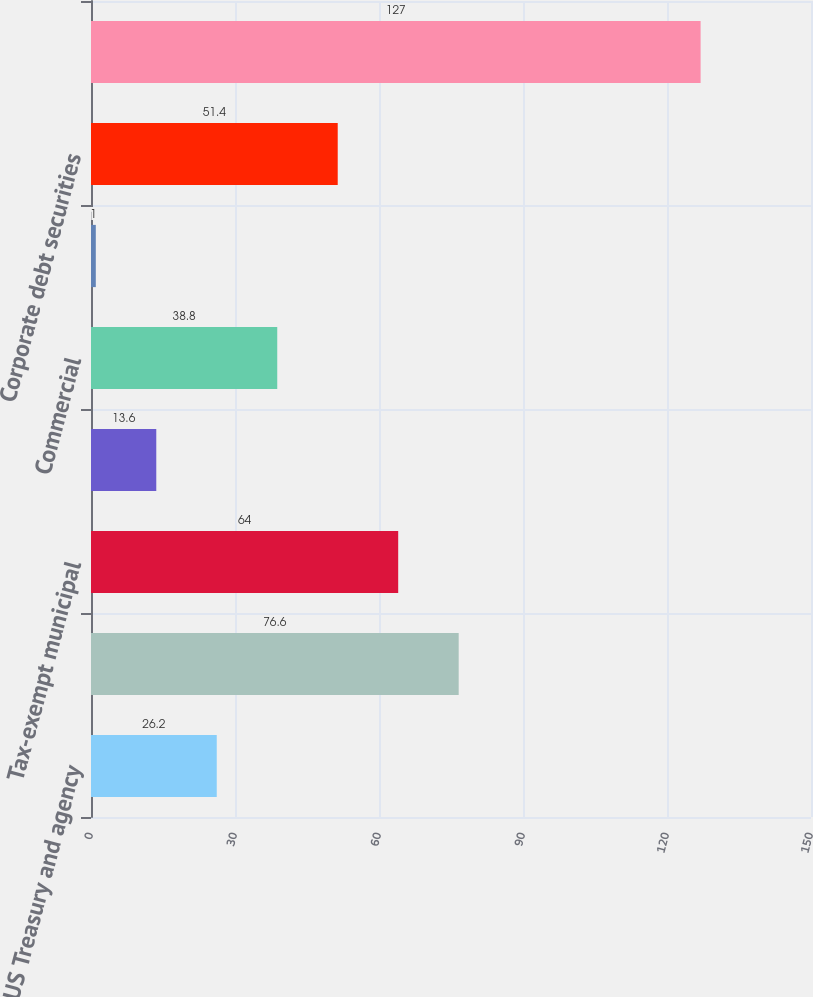Convert chart to OTSL. <chart><loc_0><loc_0><loc_500><loc_500><bar_chart><fcel>US Treasury and agency<fcel>Mortgage-backed securities<fcel>Tax-exempt municipal<fcel>Residential<fcel>Commercial<fcel>Asset-backed securities<fcel>Corporate debt securities<fcel>Total debt securities<nl><fcel>26.2<fcel>76.6<fcel>64<fcel>13.6<fcel>38.8<fcel>1<fcel>51.4<fcel>127<nl></chart> 